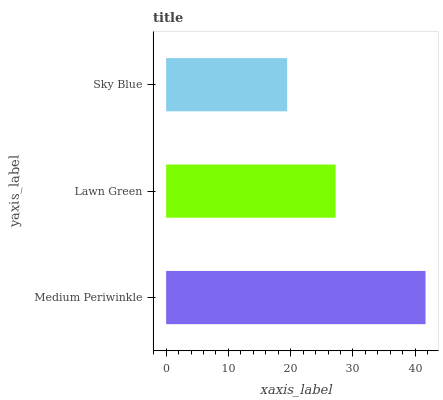Is Sky Blue the minimum?
Answer yes or no. Yes. Is Medium Periwinkle the maximum?
Answer yes or no. Yes. Is Lawn Green the minimum?
Answer yes or no. No. Is Lawn Green the maximum?
Answer yes or no. No. Is Medium Periwinkle greater than Lawn Green?
Answer yes or no. Yes. Is Lawn Green less than Medium Periwinkle?
Answer yes or no. Yes. Is Lawn Green greater than Medium Periwinkle?
Answer yes or no. No. Is Medium Periwinkle less than Lawn Green?
Answer yes or no. No. Is Lawn Green the high median?
Answer yes or no. Yes. Is Lawn Green the low median?
Answer yes or no. Yes. Is Sky Blue the high median?
Answer yes or no. No. Is Medium Periwinkle the low median?
Answer yes or no. No. 